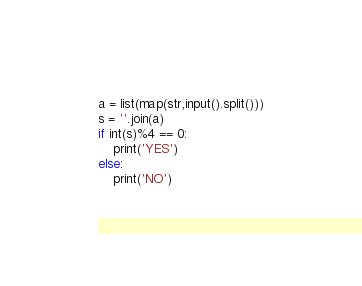<code> <loc_0><loc_0><loc_500><loc_500><_Python_>a = list(map(str,input().split()))
s = ''.join(a)
if int(s)%4 == 0:
    print('YES')
else:
    print('NO')
</code> 